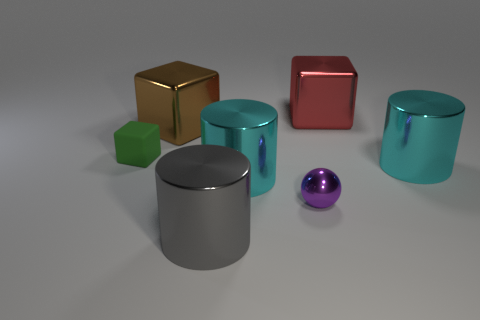Subtract all small blocks. How many blocks are left? 2 Subtract 1 blocks. How many blocks are left? 2 Add 2 cyan shiny cubes. How many objects exist? 9 Subtract all cyan blocks. Subtract all blue balls. How many blocks are left? 3 Subtract all spheres. How many objects are left? 6 Add 1 tiny purple balls. How many tiny purple balls are left? 2 Add 3 blue shiny balls. How many blue shiny balls exist? 3 Subtract 0 yellow spheres. How many objects are left? 7 Subtract all large cylinders. Subtract all tiny gray matte cylinders. How many objects are left? 4 